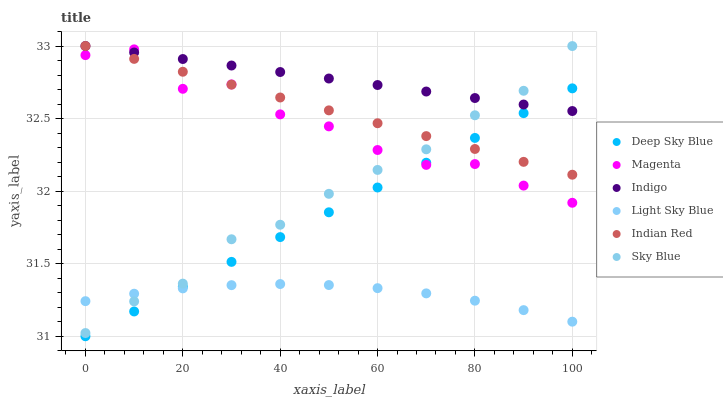Does Light Sky Blue have the minimum area under the curve?
Answer yes or no. Yes. Does Indigo have the maximum area under the curve?
Answer yes or no. Yes. Does Deep Sky Blue have the minimum area under the curve?
Answer yes or no. No. Does Deep Sky Blue have the maximum area under the curve?
Answer yes or no. No. Is Deep Sky Blue the smoothest?
Answer yes or no. Yes. Is Magenta the roughest?
Answer yes or no. Yes. Is Light Sky Blue the smoothest?
Answer yes or no. No. Is Light Sky Blue the roughest?
Answer yes or no. No. Does Deep Sky Blue have the lowest value?
Answer yes or no. Yes. Does Light Sky Blue have the lowest value?
Answer yes or no. No. Does Indian Red have the highest value?
Answer yes or no. Yes. Does Deep Sky Blue have the highest value?
Answer yes or no. No. Is Light Sky Blue less than Magenta?
Answer yes or no. Yes. Is Magenta greater than Light Sky Blue?
Answer yes or no. Yes. Does Indian Red intersect Sky Blue?
Answer yes or no. Yes. Is Indian Red less than Sky Blue?
Answer yes or no. No. Is Indian Red greater than Sky Blue?
Answer yes or no. No. Does Light Sky Blue intersect Magenta?
Answer yes or no. No. 